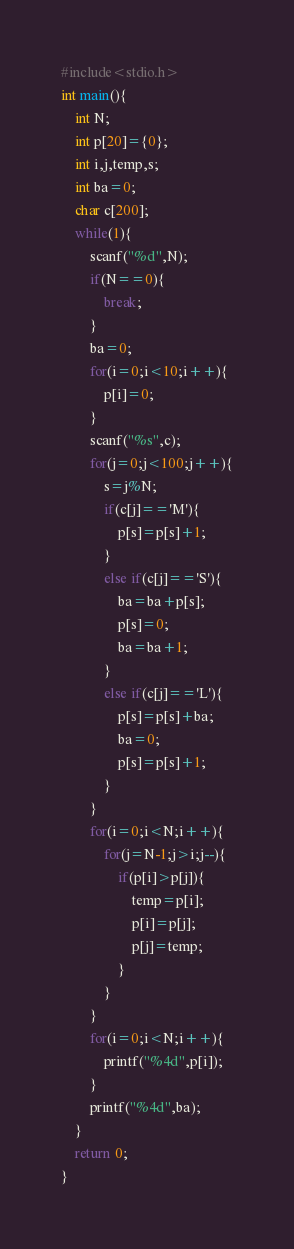<code> <loc_0><loc_0><loc_500><loc_500><_C_>#include<stdio.h>
int main(){
	int N;
	int p[20]={0};
	int i,j,temp,s;
	int ba=0;
	char c[200];
	while(1){
		scanf("%d",N);
		if(N==0){
			break;
		}
		ba=0;
		for(i=0;i<10;i++){
			p[i]=0;
		}
		scanf("%s",c);
		for(j=0;j<100;j++){
			s=j%N;
			if(c[j]=='M'){
				p[s]=p[s]+1;
			}
			else if(c[j]=='S'){
				ba=ba+p[s];
				p[s]=0;
				ba=ba+1;
			}
			else if(c[j]=='L'){
				p[s]=p[s]+ba;
				ba=0;
				p[s]=p[s]+1;
			}
		}
		for(i=0;i<N;i++){
			for(j=N-1;j>i;j--){
				if(p[i]>p[j]){
					temp=p[i];
					p[i]=p[j];
					p[j]=temp;
				}
			}
		}
		for(i=0;i<N;i++){
			printf("%4d",p[i]);
		}
		printf("%4d",ba);
	}
	return 0;
}</code> 